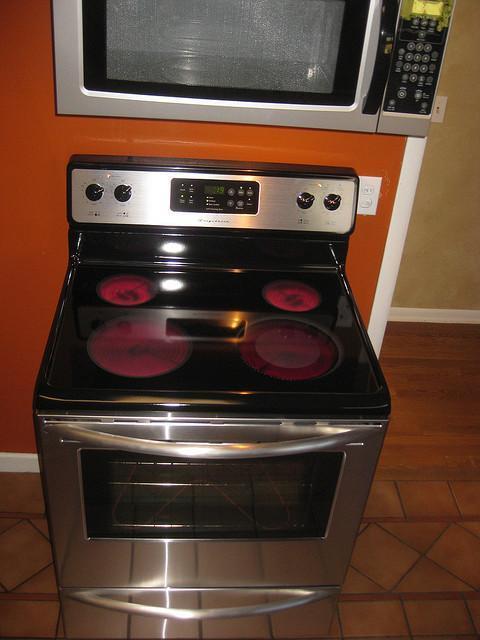How many people are wearing red shirt?
Give a very brief answer. 0. 